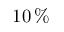<formula> <loc_0><loc_0><loc_500><loc_500>1 0 \, \%</formula> 